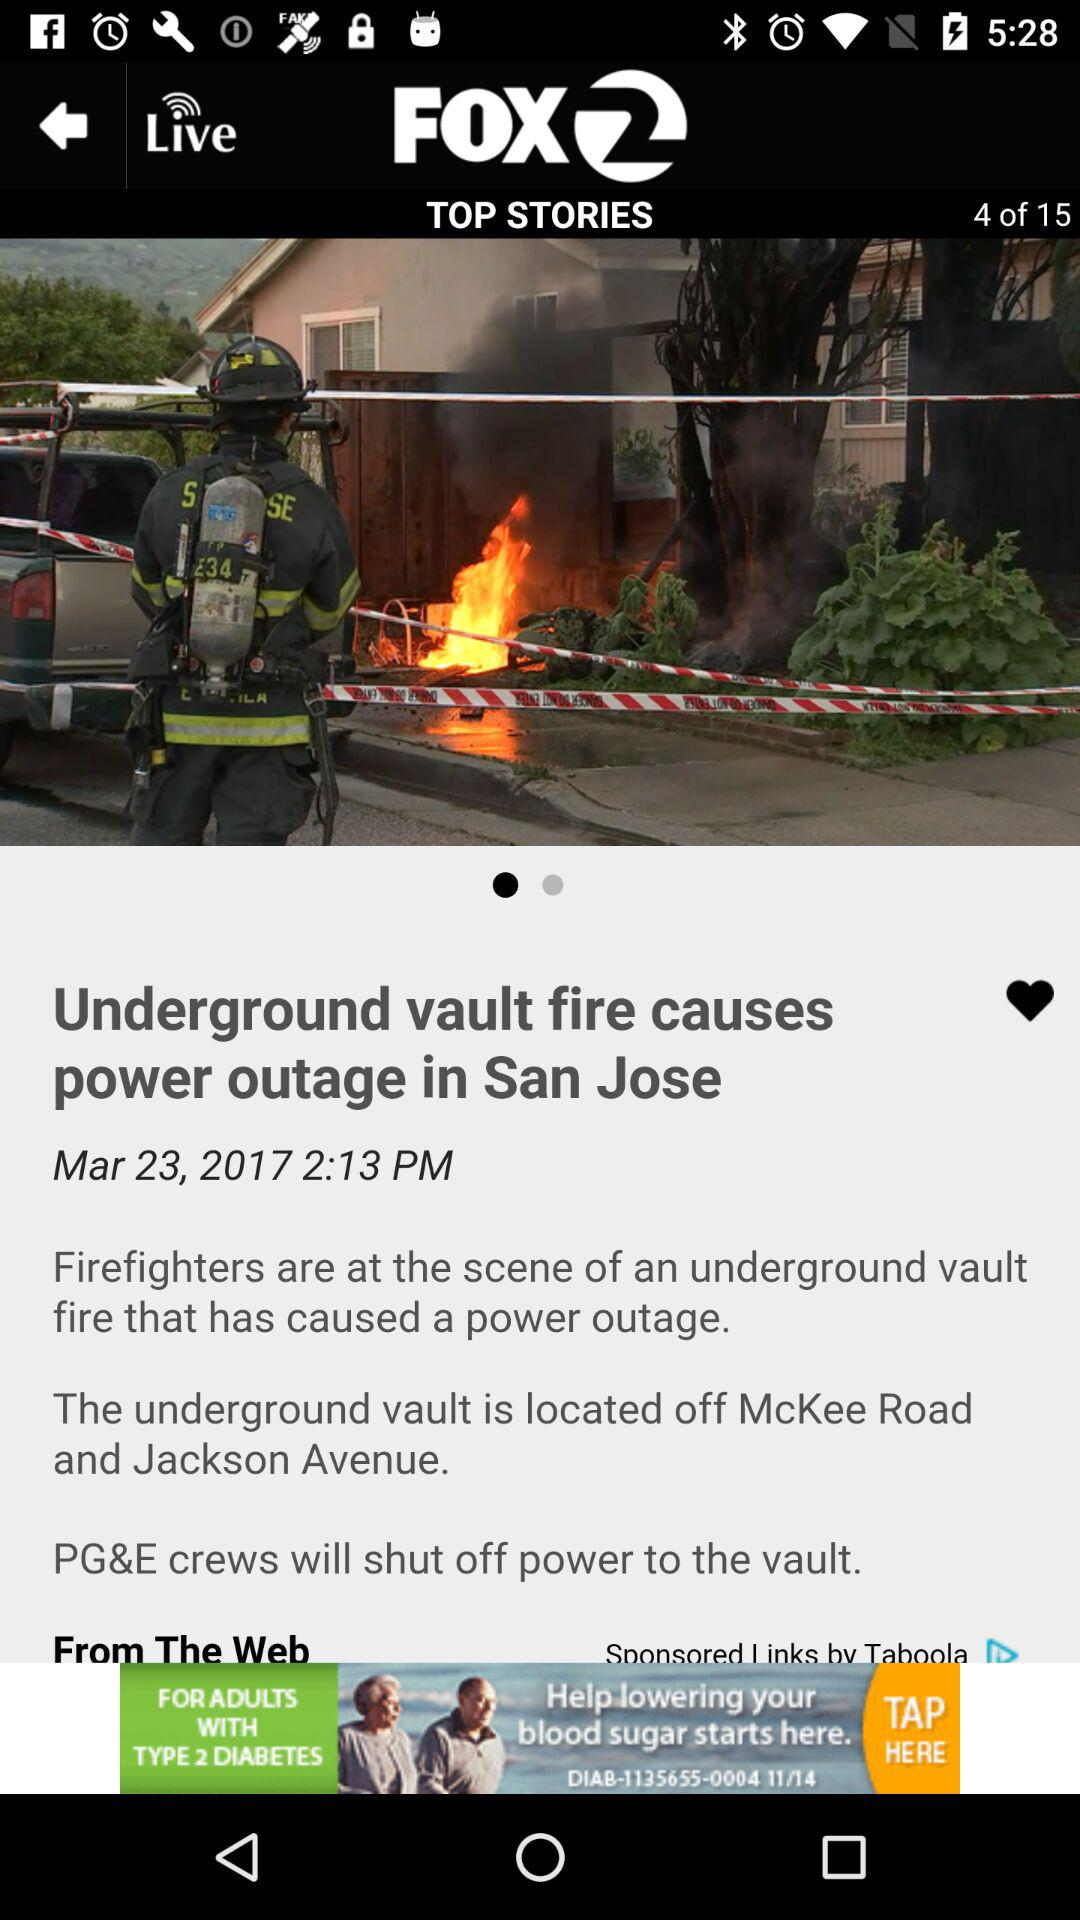What is the publication date of the article "Underground vault fire causes power outage in San Jose"? The publication date is March 23, 2017. 